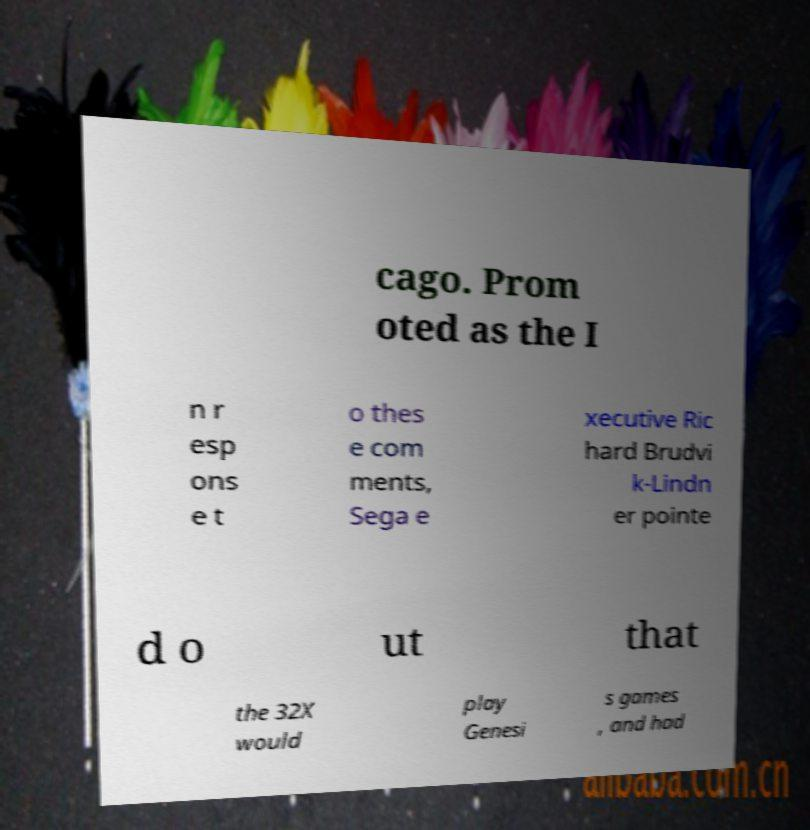Can you read and provide the text displayed in the image?This photo seems to have some interesting text. Can you extract and type it out for me? cago. Prom oted as the I n r esp ons e t o thes e com ments, Sega e xecutive Ric hard Brudvi k-Lindn er pointe d o ut that the 32X would play Genesi s games , and had 